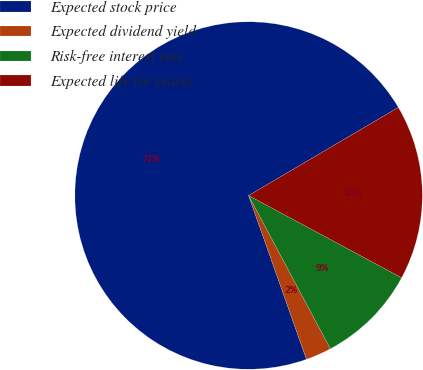Convert chart. <chart><loc_0><loc_0><loc_500><loc_500><pie_chart><fcel>Expected stock price<fcel>Expected dividend yield<fcel>Risk-free interest rate<fcel>Expected life (in years)<nl><fcel>71.94%<fcel>2.4%<fcel>9.35%<fcel>16.31%<nl></chart> 